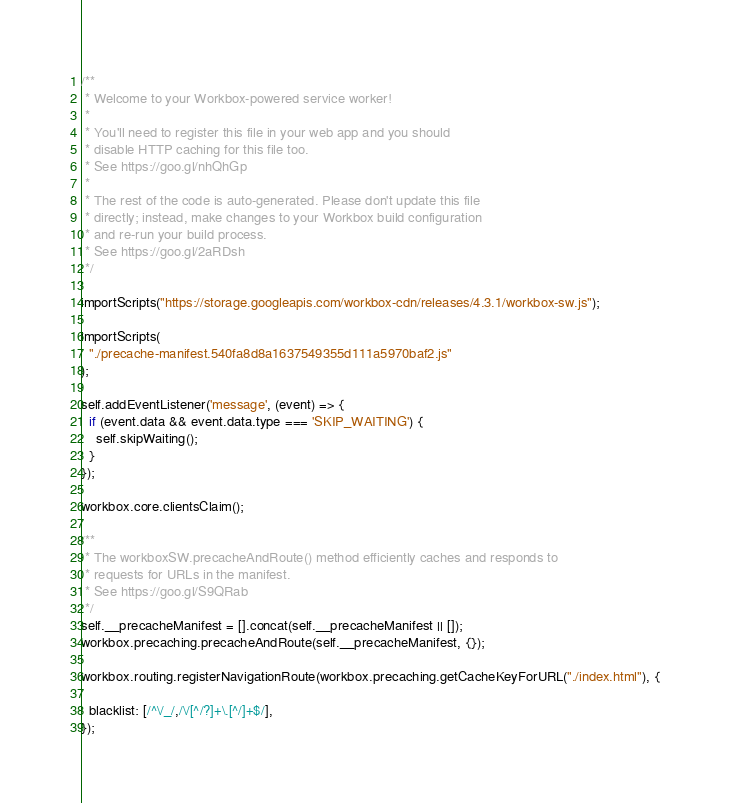<code> <loc_0><loc_0><loc_500><loc_500><_JavaScript_>/**
 * Welcome to your Workbox-powered service worker!
 *
 * You'll need to register this file in your web app and you should
 * disable HTTP caching for this file too.
 * See https://goo.gl/nhQhGp
 *
 * The rest of the code is auto-generated. Please don't update this file
 * directly; instead, make changes to your Workbox build configuration
 * and re-run your build process.
 * See https://goo.gl/2aRDsh
 */

importScripts("https://storage.googleapis.com/workbox-cdn/releases/4.3.1/workbox-sw.js");

importScripts(
  "./precache-manifest.540fa8d8a1637549355d111a5970baf2.js"
);

self.addEventListener('message', (event) => {
  if (event.data && event.data.type === 'SKIP_WAITING') {
    self.skipWaiting();
  }
});

workbox.core.clientsClaim();

/**
 * The workboxSW.precacheAndRoute() method efficiently caches and responds to
 * requests for URLs in the manifest.
 * See https://goo.gl/S9QRab
 */
self.__precacheManifest = [].concat(self.__precacheManifest || []);
workbox.precaching.precacheAndRoute(self.__precacheManifest, {});

workbox.routing.registerNavigationRoute(workbox.precaching.getCacheKeyForURL("./index.html"), {
  
  blacklist: [/^\/_/,/\/[^/?]+\.[^/]+$/],
});
</code> 